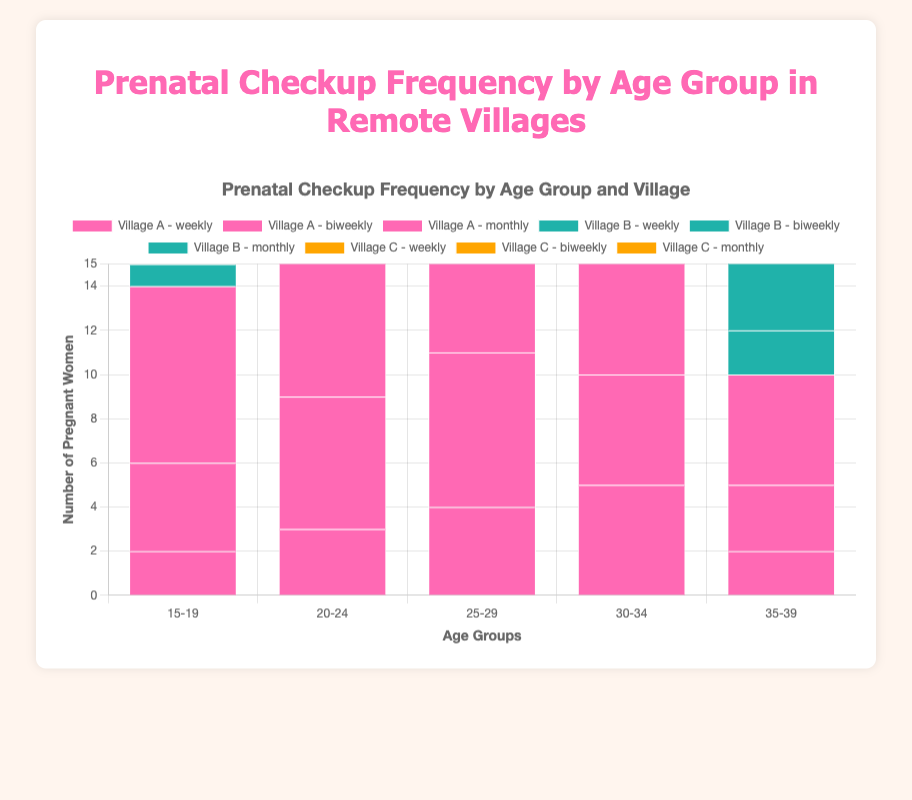How many women aged 25-29 in Village A receive weekly or biweekly checkups? In Village A, the number of 25-29 aged women receiving weekly checkups is 4 and biweekly checkups is 7. Therefore, the total is 4 + 7 = 11.
Answer: 11 Which age group in Village B has the highest number of monthly checkups? In Village B, the number of monthly checkups by age group are 7 (15-19), 11 (20-24), 13 (25-29), 5 (30-34), and 6 (35-39). The age group with the highest number is 25-29 with 13 monthly checkups.
Answer: 25-29 Comparing the age group 30-34 in Village A and Village C, which village has more weekly checkups? For the age group 30-34, Village A has 5 weekly checkups, and Village C has 2 weekly checkups. Village A has more weekly checkups.
Answer: Village A Which village has the lowest biweekly checkups for women aged 35-39? For women aged 35-39, the biweekly checkups across villages are 3 (Village A), 2 (Village B), and 3 (Village C). Village B has the lowest biweekly checkups with 2.
Answer: Village B What is the total number of weekly checkups for all age groups in Village A? In Village A, weekly checkups by age group are 2 (15-19), 3 (20-24), 4 (25-29), 5 (30-34), and 2 (35-39). The total is 2 + 3 + 4 + 5 + 2 = 16.
Answer: 16 Across all villages, which age group receives the highest number of biweekly checkups? Summarizing biweekly checkups for each age group across all villages: 9 (15-19), 15 (20-24), 21 (25-29), 12 (30-34), and 8 (35-39). The age group 25-29 has the highest with 21 biweekly checkups.
Answer: 25-29 For women aged 20-24, compare the total monthly checkups between Village A and Village B For women aged 20-24, Village A has 12 monthly checkups and Village B has 11 monthly checkups. Thus, Village A has more monthly checkups.
Answer: Village A What is the average number of weekly checkups for women aged 20-24 across all villages? The weekly checkups for women aged 20-24 are 3 (Village A), 3 (Village B), and 3 (Village C). The average is (3 + 3 + 3) / 3 = 3.
Answer: 3 